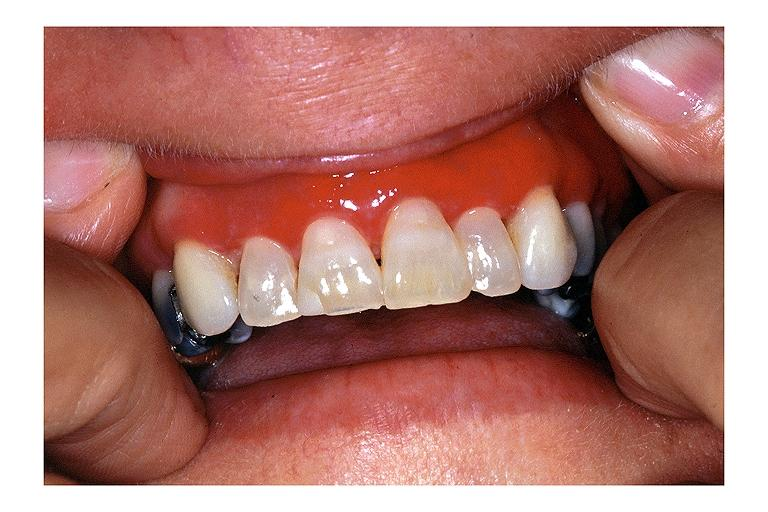what does this image show?
Answer the question using a single word or phrase. Desquamative gingivits 